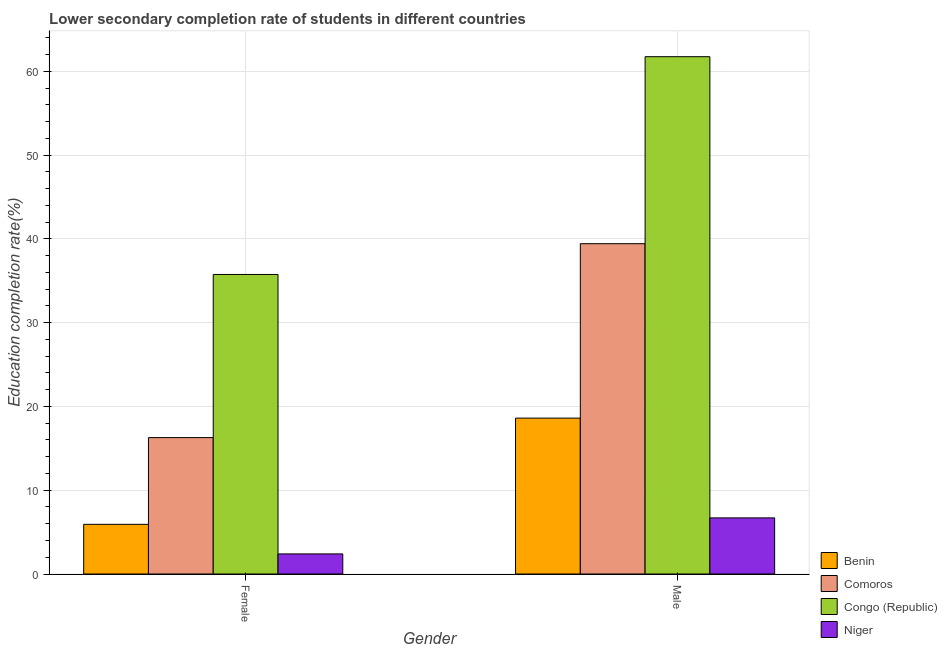Are the number of bars on each tick of the X-axis equal?
Offer a very short reply. Yes. What is the label of the 2nd group of bars from the left?
Keep it short and to the point. Male. What is the education completion rate of female students in Niger?
Your answer should be compact. 2.4. Across all countries, what is the maximum education completion rate of male students?
Offer a very short reply. 61.74. Across all countries, what is the minimum education completion rate of male students?
Offer a very short reply. 6.7. In which country was the education completion rate of male students maximum?
Keep it short and to the point. Congo (Republic). In which country was the education completion rate of female students minimum?
Your answer should be very brief. Niger. What is the total education completion rate of female students in the graph?
Ensure brevity in your answer.  60.35. What is the difference between the education completion rate of female students in Congo (Republic) and that in Comoros?
Offer a terse response. 19.47. What is the difference between the education completion rate of female students in Congo (Republic) and the education completion rate of male students in Niger?
Offer a very short reply. 29.05. What is the average education completion rate of female students per country?
Your answer should be compact. 15.09. What is the difference between the education completion rate of male students and education completion rate of female students in Congo (Republic)?
Provide a succinct answer. 25.99. What is the ratio of the education completion rate of female students in Comoros to that in Benin?
Provide a short and direct response. 2.75. In how many countries, is the education completion rate of female students greater than the average education completion rate of female students taken over all countries?
Provide a short and direct response. 2. What does the 4th bar from the left in Male represents?
Keep it short and to the point. Niger. What does the 2nd bar from the right in Male represents?
Ensure brevity in your answer.  Congo (Republic). How many countries are there in the graph?
Keep it short and to the point. 4. Are the values on the major ticks of Y-axis written in scientific E-notation?
Provide a succinct answer. No. Does the graph contain grids?
Make the answer very short. Yes. How many legend labels are there?
Your response must be concise. 4. What is the title of the graph?
Give a very brief answer. Lower secondary completion rate of students in different countries. Does "Thailand" appear as one of the legend labels in the graph?
Provide a succinct answer. No. What is the label or title of the Y-axis?
Ensure brevity in your answer.  Education completion rate(%). What is the Education completion rate(%) in Benin in Female?
Provide a short and direct response. 5.93. What is the Education completion rate(%) in Comoros in Female?
Provide a short and direct response. 16.28. What is the Education completion rate(%) in Congo (Republic) in Female?
Offer a terse response. 35.75. What is the Education completion rate(%) in Niger in Female?
Make the answer very short. 2.4. What is the Education completion rate(%) in Benin in Male?
Your answer should be very brief. 18.6. What is the Education completion rate(%) in Comoros in Male?
Offer a very short reply. 39.42. What is the Education completion rate(%) of Congo (Republic) in Male?
Keep it short and to the point. 61.74. What is the Education completion rate(%) in Niger in Male?
Offer a very short reply. 6.7. Across all Gender, what is the maximum Education completion rate(%) of Benin?
Ensure brevity in your answer.  18.6. Across all Gender, what is the maximum Education completion rate(%) of Comoros?
Keep it short and to the point. 39.42. Across all Gender, what is the maximum Education completion rate(%) in Congo (Republic)?
Your response must be concise. 61.74. Across all Gender, what is the maximum Education completion rate(%) in Niger?
Provide a short and direct response. 6.7. Across all Gender, what is the minimum Education completion rate(%) of Benin?
Your answer should be compact. 5.93. Across all Gender, what is the minimum Education completion rate(%) of Comoros?
Keep it short and to the point. 16.28. Across all Gender, what is the minimum Education completion rate(%) of Congo (Republic)?
Keep it short and to the point. 35.75. Across all Gender, what is the minimum Education completion rate(%) in Niger?
Your response must be concise. 2.4. What is the total Education completion rate(%) in Benin in the graph?
Offer a very short reply. 24.53. What is the total Education completion rate(%) in Comoros in the graph?
Your answer should be compact. 55.7. What is the total Education completion rate(%) of Congo (Republic) in the graph?
Your answer should be very brief. 97.49. What is the total Education completion rate(%) in Niger in the graph?
Keep it short and to the point. 9.09. What is the difference between the Education completion rate(%) of Benin in Female and that in Male?
Offer a very short reply. -12.68. What is the difference between the Education completion rate(%) of Comoros in Female and that in Male?
Keep it short and to the point. -23.14. What is the difference between the Education completion rate(%) of Congo (Republic) in Female and that in Male?
Provide a short and direct response. -25.99. What is the difference between the Education completion rate(%) in Niger in Female and that in Male?
Give a very brief answer. -4.3. What is the difference between the Education completion rate(%) in Benin in Female and the Education completion rate(%) in Comoros in Male?
Offer a terse response. -33.49. What is the difference between the Education completion rate(%) in Benin in Female and the Education completion rate(%) in Congo (Republic) in Male?
Provide a succinct answer. -55.81. What is the difference between the Education completion rate(%) of Benin in Female and the Education completion rate(%) of Niger in Male?
Make the answer very short. -0.77. What is the difference between the Education completion rate(%) of Comoros in Female and the Education completion rate(%) of Congo (Republic) in Male?
Keep it short and to the point. -45.46. What is the difference between the Education completion rate(%) of Comoros in Female and the Education completion rate(%) of Niger in Male?
Give a very brief answer. 9.58. What is the difference between the Education completion rate(%) in Congo (Republic) in Female and the Education completion rate(%) in Niger in Male?
Offer a terse response. 29.05. What is the average Education completion rate(%) in Benin per Gender?
Give a very brief answer. 12.27. What is the average Education completion rate(%) of Comoros per Gender?
Offer a very short reply. 27.85. What is the average Education completion rate(%) in Congo (Republic) per Gender?
Keep it short and to the point. 48.74. What is the average Education completion rate(%) in Niger per Gender?
Give a very brief answer. 4.55. What is the difference between the Education completion rate(%) of Benin and Education completion rate(%) of Comoros in Female?
Keep it short and to the point. -10.35. What is the difference between the Education completion rate(%) of Benin and Education completion rate(%) of Congo (Republic) in Female?
Ensure brevity in your answer.  -29.82. What is the difference between the Education completion rate(%) in Benin and Education completion rate(%) in Niger in Female?
Make the answer very short. 3.53. What is the difference between the Education completion rate(%) in Comoros and Education completion rate(%) in Congo (Republic) in Female?
Offer a very short reply. -19.47. What is the difference between the Education completion rate(%) of Comoros and Education completion rate(%) of Niger in Female?
Provide a succinct answer. 13.88. What is the difference between the Education completion rate(%) in Congo (Republic) and Education completion rate(%) in Niger in Female?
Offer a very short reply. 33.35. What is the difference between the Education completion rate(%) of Benin and Education completion rate(%) of Comoros in Male?
Make the answer very short. -20.82. What is the difference between the Education completion rate(%) of Benin and Education completion rate(%) of Congo (Republic) in Male?
Your answer should be very brief. -43.13. What is the difference between the Education completion rate(%) in Benin and Education completion rate(%) in Niger in Male?
Give a very brief answer. 11.91. What is the difference between the Education completion rate(%) of Comoros and Education completion rate(%) of Congo (Republic) in Male?
Keep it short and to the point. -22.32. What is the difference between the Education completion rate(%) of Comoros and Education completion rate(%) of Niger in Male?
Your answer should be very brief. 32.72. What is the difference between the Education completion rate(%) in Congo (Republic) and Education completion rate(%) in Niger in Male?
Your response must be concise. 55.04. What is the ratio of the Education completion rate(%) in Benin in Female to that in Male?
Offer a very short reply. 0.32. What is the ratio of the Education completion rate(%) of Comoros in Female to that in Male?
Your answer should be compact. 0.41. What is the ratio of the Education completion rate(%) in Congo (Republic) in Female to that in Male?
Make the answer very short. 0.58. What is the ratio of the Education completion rate(%) in Niger in Female to that in Male?
Offer a terse response. 0.36. What is the difference between the highest and the second highest Education completion rate(%) in Benin?
Give a very brief answer. 12.68. What is the difference between the highest and the second highest Education completion rate(%) in Comoros?
Your answer should be very brief. 23.14. What is the difference between the highest and the second highest Education completion rate(%) in Congo (Republic)?
Offer a very short reply. 25.99. What is the difference between the highest and the second highest Education completion rate(%) in Niger?
Provide a succinct answer. 4.3. What is the difference between the highest and the lowest Education completion rate(%) of Benin?
Your answer should be very brief. 12.68. What is the difference between the highest and the lowest Education completion rate(%) in Comoros?
Give a very brief answer. 23.14. What is the difference between the highest and the lowest Education completion rate(%) in Congo (Republic)?
Make the answer very short. 25.99. What is the difference between the highest and the lowest Education completion rate(%) of Niger?
Your response must be concise. 4.3. 